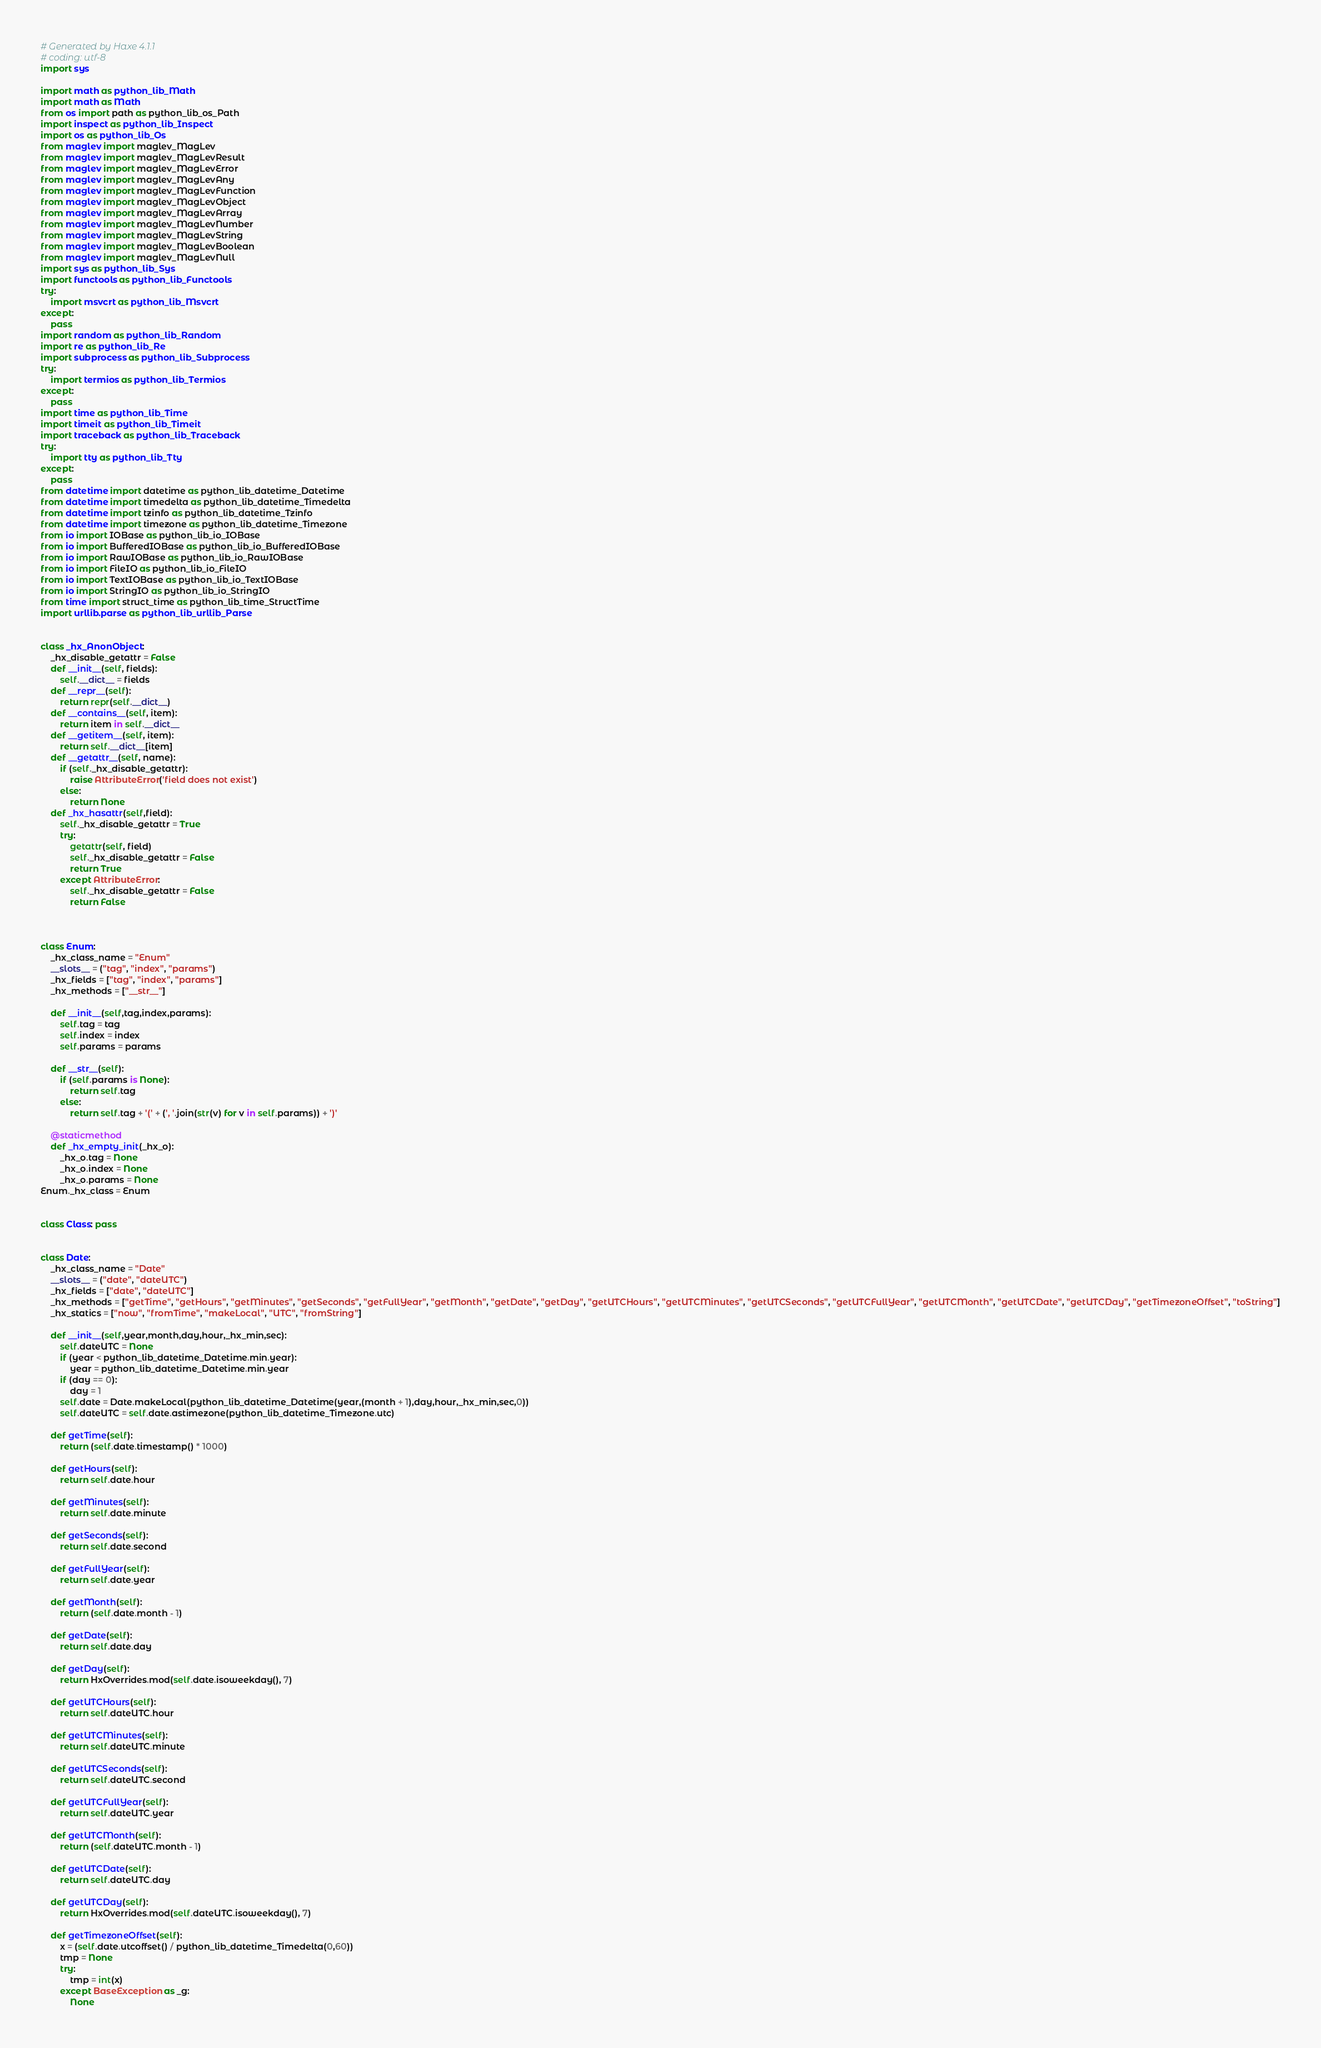Convert code to text. <code><loc_0><loc_0><loc_500><loc_500><_Python_># Generated by Haxe 4.1.1
# coding: utf-8
import sys

import math as python_lib_Math
import math as Math
from os import path as python_lib_os_Path
import inspect as python_lib_Inspect
import os as python_lib_Os
from maglev import maglev_MagLev
from maglev import maglev_MagLevResult
from maglev import maglev_MagLevError
from maglev import maglev_MagLevAny
from maglev import maglev_MagLevFunction
from maglev import maglev_MagLevObject
from maglev import maglev_MagLevArray
from maglev import maglev_MagLevNumber
from maglev import maglev_MagLevString
from maglev import maglev_MagLevBoolean
from maglev import maglev_MagLevNull
import sys as python_lib_Sys
import functools as python_lib_Functools
try:
    import msvcrt as python_lib_Msvcrt
except:
    pass
import random as python_lib_Random
import re as python_lib_Re
import subprocess as python_lib_Subprocess
try:
    import termios as python_lib_Termios
except:
    pass
import time as python_lib_Time
import timeit as python_lib_Timeit
import traceback as python_lib_Traceback
try:
    import tty as python_lib_Tty
except:
    pass
from datetime import datetime as python_lib_datetime_Datetime
from datetime import timedelta as python_lib_datetime_Timedelta
from datetime import tzinfo as python_lib_datetime_Tzinfo
from datetime import timezone as python_lib_datetime_Timezone
from io import IOBase as python_lib_io_IOBase
from io import BufferedIOBase as python_lib_io_BufferedIOBase
from io import RawIOBase as python_lib_io_RawIOBase
from io import FileIO as python_lib_io_FileIO
from io import TextIOBase as python_lib_io_TextIOBase
from io import StringIO as python_lib_io_StringIO
from time import struct_time as python_lib_time_StructTime
import urllib.parse as python_lib_urllib_Parse


class _hx_AnonObject:
    _hx_disable_getattr = False
    def __init__(self, fields):
        self.__dict__ = fields
    def __repr__(self):
        return repr(self.__dict__)
    def __contains__(self, item):
        return item in self.__dict__
    def __getitem__(self, item):
        return self.__dict__[item]
    def __getattr__(self, name):
        if (self._hx_disable_getattr):
            raise AttributeError('field does not exist')
        else:
            return None
    def _hx_hasattr(self,field):
        self._hx_disable_getattr = True
        try:
            getattr(self, field)
            self._hx_disable_getattr = False
            return True
        except AttributeError:
            self._hx_disable_getattr = False
            return False



class Enum:
    _hx_class_name = "Enum"
    __slots__ = ("tag", "index", "params")
    _hx_fields = ["tag", "index", "params"]
    _hx_methods = ["__str__"]

    def __init__(self,tag,index,params):
        self.tag = tag
        self.index = index
        self.params = params

    def __str__(self):
        if (self.params is None):
            return self.tag
        else:
            return self.tag + '(' + (', '.join(str(v) for v in self.params)) + ')'

    @staticmethod
    def _hx_empty_init(_hx_o):
        _hx_o.tag = None
        _hx_o.index = None
        _hx_o.params = None
Enum._hx_class = Enum


class Class: pass


class Date:
    _hx_class_name = "Date"
    __slots__ = ("date", "dateUTC")
    _hx_fields = ["date", "dateUTC"]
    _hx_methods = ["getTime", "getHours", "getMinutes", "getSeconds", "getFullYear", "getMonth", "getDate", "getDay", "getUTCHours", "getUTCMinutes", "getUTCSeconds", "getUTCFullYear", "getUTCMonth", "getUTCDate", "getUTCDay", "getTimezoneOffset", "toString"]
    _hx_statics = ["now", "fromTime", "makeLocal", "UTC", "fromString"]

    def __init__(self,year,month,day,hour,_hx_min,sec):
        self.dateUTC = None
        if (year < python_lib_datetime_Datetime.min.year):
            year = python_lib_datetime_Datetime.min.year
        if (day == 0):
            day = 1
        self.date = Date.makeLocal(python_lib_datetime_Datetime(year,(month + 1),day,hour,_hx_min,sec,0))
        self.dateUTC = self.date.astimezone(python_lib_datetime_Timezone.utc)

    def getTime(self):
        return (self.date.timestamp() * 1000)

    def getHours(self):
        return self.date.hour

    def getMinutes(self):
        return self.date.minute

    def getSeconds(self):
        return self.date.second

    def getFullYear(self):
        return self.date.year

    def getMonth(self):
        return (self.date.month - 1)

    def getDate(self):
        return self.date.day

    def getDay(self):
        return HxOverrides.mod(self.date.isoweekday(), 7)

    def getUTCHours(self):
        return self.dateUTC.hour

    def getUTCMinutes(self):
        return self.dateUTC.minute

    def getUTCSeconds(self):
        return self.dateUTC.second

    def getUTCFullYear(self):
        return self.dateUTC.year

    def getUTCMonth(self):
        return (self.dateUTC.month - 1)

    def getUTCDate(self):
        return self.dateUTC.day

    def getUTCDay(self):
        return HxOverrides.mod(self.dateUTC.isoweekday(), 7)

    def getTimezoneOffset(self):
        x = (self.date.utcoffset() / python_lib_datetime_Timedelta(0,60))
        tmp = None
        try:
            tmp = int(x)
        except BaseException as _g:
            None</code> 